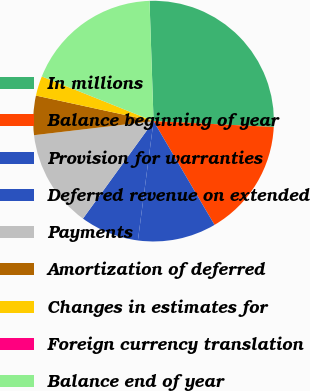<chart> <loc_0><loc_0><loc_500><loc_500><pie_chart><fcel>In millions<fcel>Balance beginning of year<fcel>Provision for warranties<fcel>Deferred revenue on extended<fcel>Payments<fcel>Amortization of deferred<fcel>Changes in estimates for<fcel>Foreign currency translation<fcel>Balance end of year<nl><fcel>26.3%<fcel>15.78%<fcel>10.53%<fcel>7.9%<fcel>13.16%<fcel>5.27%<fcel>2.64%<fcel>0.01%<fcel>18.41%<nl></chart> 